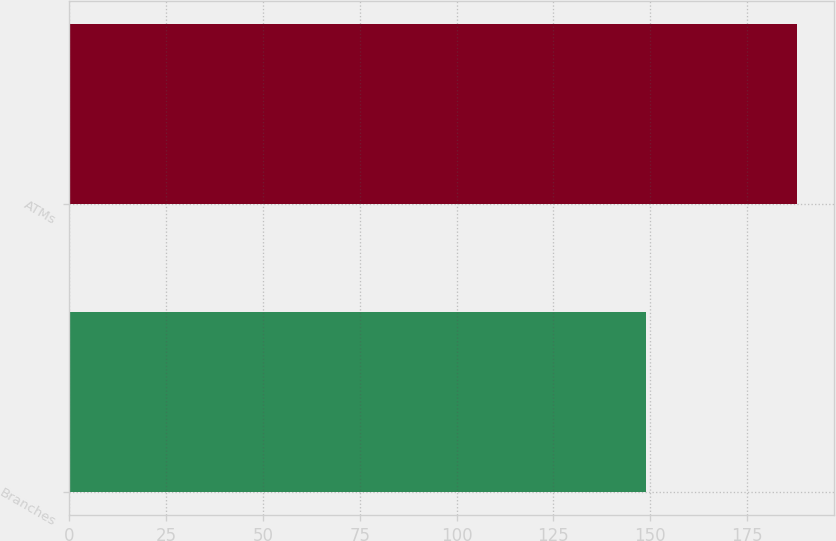Convert chart to OTSL. <chart><loc_0><loc_0><loc_500><loc_500><bar_chart><fcel>Branches<fcel>ATMs<nl><fcel>149<fcel>188<nl></chart> 